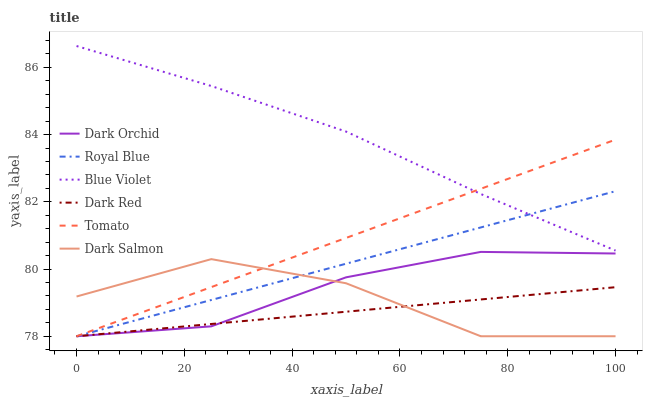Does Dark Salmon have the minimum area under the curve?
Answer yes or no. No. Does Dark Salmon have the maximum area under the curve?
Answer yes or no. No. Is Dark Salmon the smoothest?
Answer yes or no. No. Is Dark Red the roughest?
Answer yes or no. No. Does Blue Violet have the lowest value?
Answer yes or no. No. Does Dark Salmon have the highest value?
Answer yes or no. No. Is Dark Red less than Blue Violet?
Answer yes or no. Yes. Is Blue Violet greater than Dark Salmon?
Answer yes or no. Yes. Does Dark Red intersect Blue Violet?
Answer yes or no. No. 